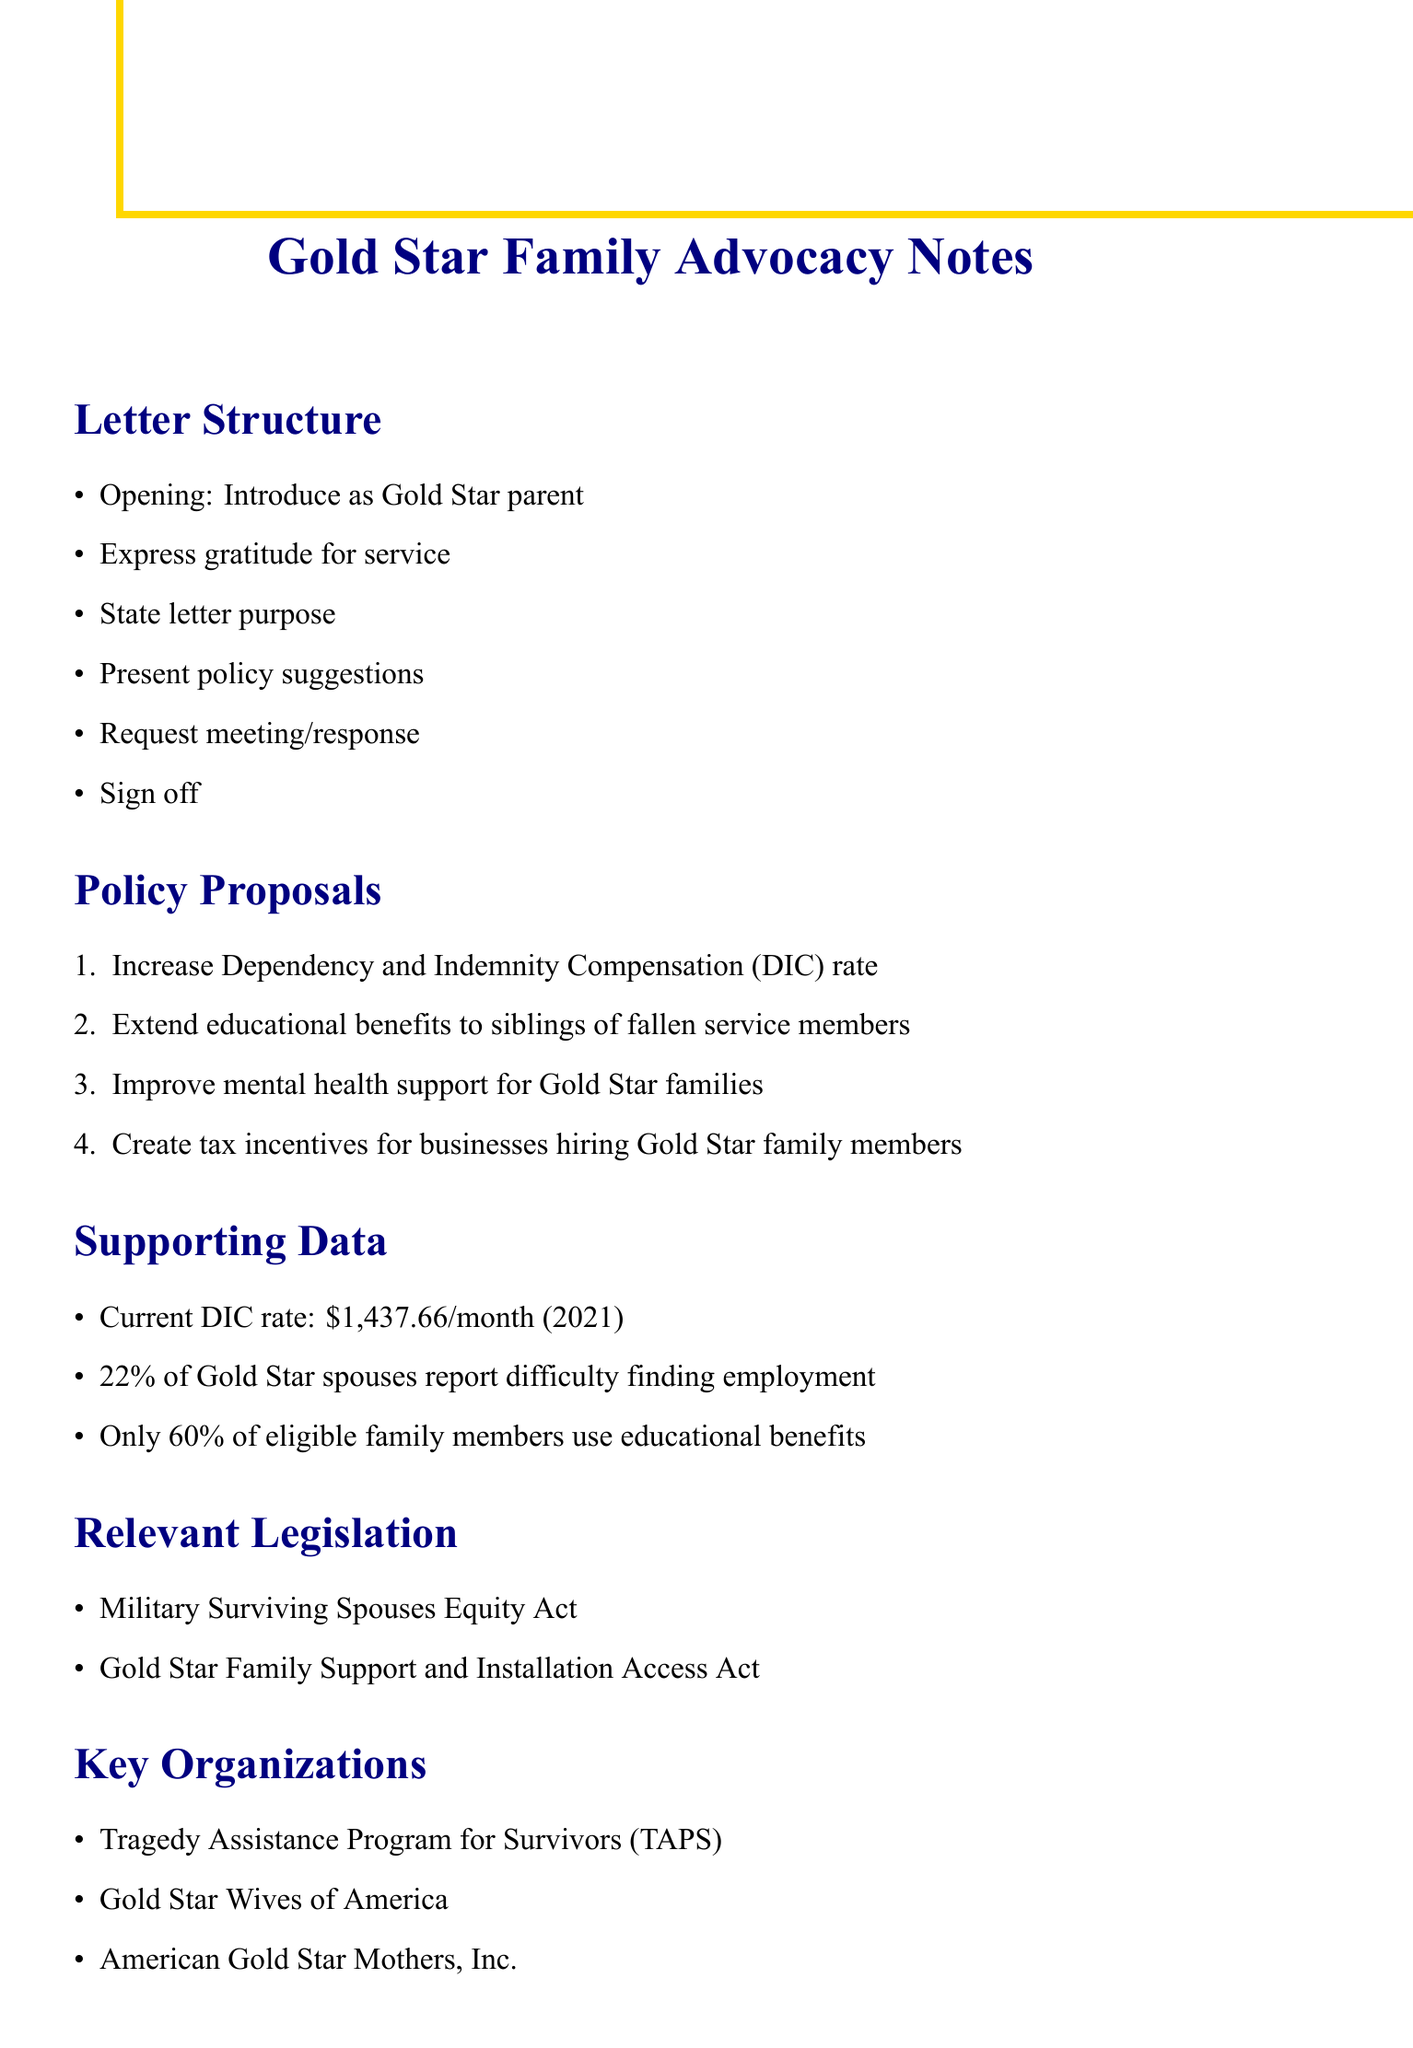What is the current DIC rate? The current DIC rate is specified in the supporting data as $1,437.66 per month as of 2021.
Answer: $1,437.66 per month What percentage of Gold Star spouses report employment difficulties? This percentage can be found in the supporting data, indicating a specific challenge faced by Gold Star families.
Answer: 22% What is one key organization mentioned in the document? The document lists several key organizations that support Gold Star families; one example is provided in the key organizations section.
Answer: Tragedy Assistance Program for Survivors (TAPS) What policy proposal suggests improving educational support? The policy proposals include suggestions for enhancing benefits for educational opportunities, one being specifically related to siblings of fallen service members.
Answer: Extend educational benefits to siblings of fallen service members What is the purpose of the letter? The document structure outlines the intent of the letter in that specific section, which identifies why the writer is reaching out to representatives.
Answer: Advocate for improved benefits and support for Gold Star families Which legislation is relevant to Gold Star family advocacy? The document references specific legislation that supports Gold Star families, making it essential for framing the policy context.
Answer: Military Surviving Spouses Equity Act How can businesses support Gold Star families according to the proposals? One specific policy suggestion points towards providing incentives for businesses involving Gold Star family members, addressing their integration into the workforce.
Answer: Create tax incentives for businesses hiring Gold Star family members What personal touchpoint is suggested to include in the letter? The personal touchpoints section of the document outlines narratives to enhance the connection with the audience, asking for a mention of personal experiences.
Answer: Brief mention of your fallen service member 